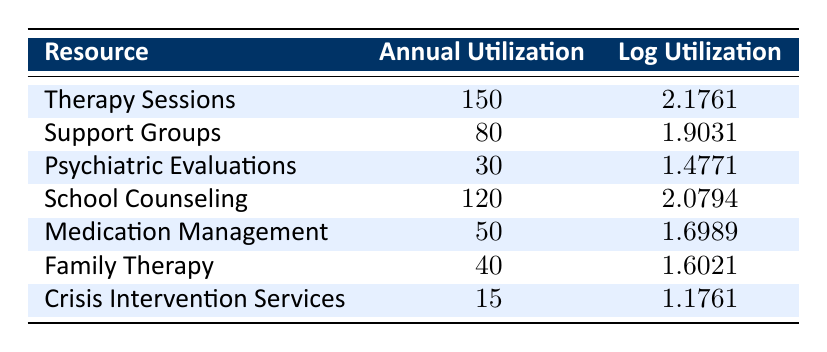What is the annual utilization of Therapy Sessions? The table lists annual utilization for various resources, and Therapy Sessions are indicated with an annual utilization of 150.
Answer: 150 How many more Support Groups are utilized compared to Crisis Intervention Services? Support Groups have an annual utilization of 80, while Crisis Intervention Services have 15. Subtracting these gives 80 - 15 = 65.
Answer: 65 Is the log utilization for School Counseling higher than that for Medication Management? The log utilization for School Counseling is 2.0794 and for Medication Management is 1.6989. Since 2.0794 is greater than 1.6989, the statement is true.
Answer: Yes What resource has the lowest annual utilization? By comparing all annual utilizations in the table, Crisis Intervention Services has the lowest at 15.
Answer: Crisis Intervention Services What is the total annual utilization for all resources listed? Summing the annual utilizations: 150 + 80 + 30 + 120 + 50 + 40 + 15 = 485.
Answer: 485 What is the average log utilization across all listed resources? First sum the log utilizations: 2.1761 + 1.9031 + 1.4771 + 2.0794 + 1.6989 + 1.6021 + 1.1761 = 12.1128. There are 7 resources, so the average is 12.1128 / 7 ≈ 1.7304.
Answer: 1.7304 Do both Family Therapy and Psychiatric Evaluations have annual utilizations above 25? Family Therapy has an annual utilization of 40 and Psychiatric Evaluations have 30. Both values exceed 25, so the answer is yes.
Answer: Yes Which resource has the highest log utilization? By examining the log utilizations, Therapy Sessions have 2.1761, which is the highest value compared to others listed.
Answer: Therapy Sessions What is the difference in annual utilization between Therapy Sessions and School Counseling? Therapy Sessions have an annual utilization of 150, while School Counseling has 120. Subtracting these provides 150 - 120 = 30.
Answer: 30 